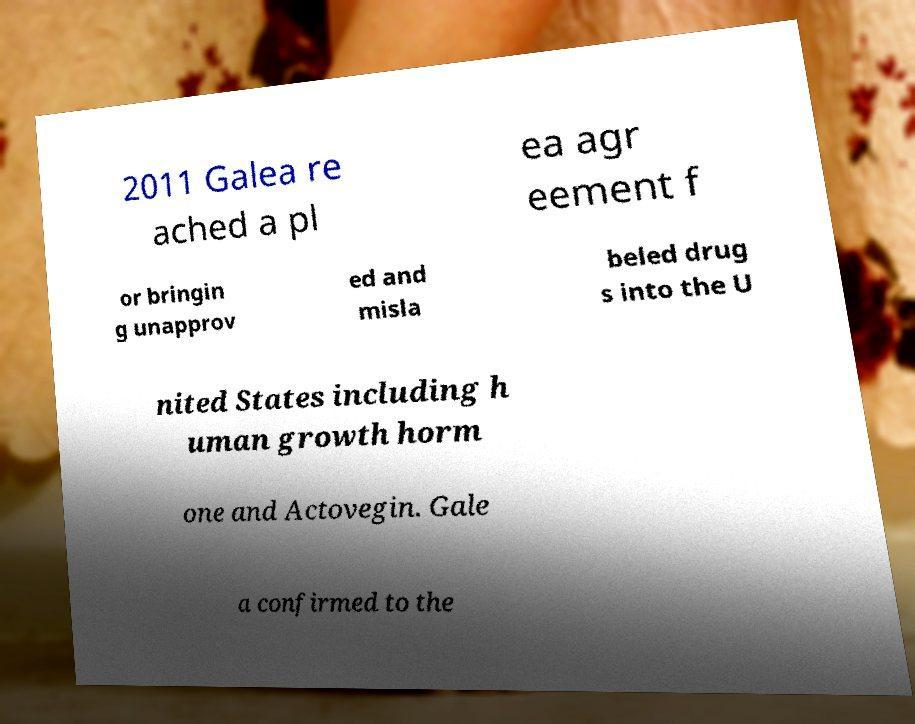Can you read and provide the text displayed in the image?This photo seems to have some interesting text. Can you extract and type it out for me? 2011 Galea re ached a pl ea agr eement f or bringin g unapprov ed and misla beled drug s into the U nited States including h uman growth horm one and Actovegin. Gale a confirmed to the 